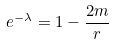Convert formula to latex. <formula><loc_0><loc_0><loc_500><loc_500>e ^ { - \lambda } = 1 - \frac { 2 m } { r }</formula> 